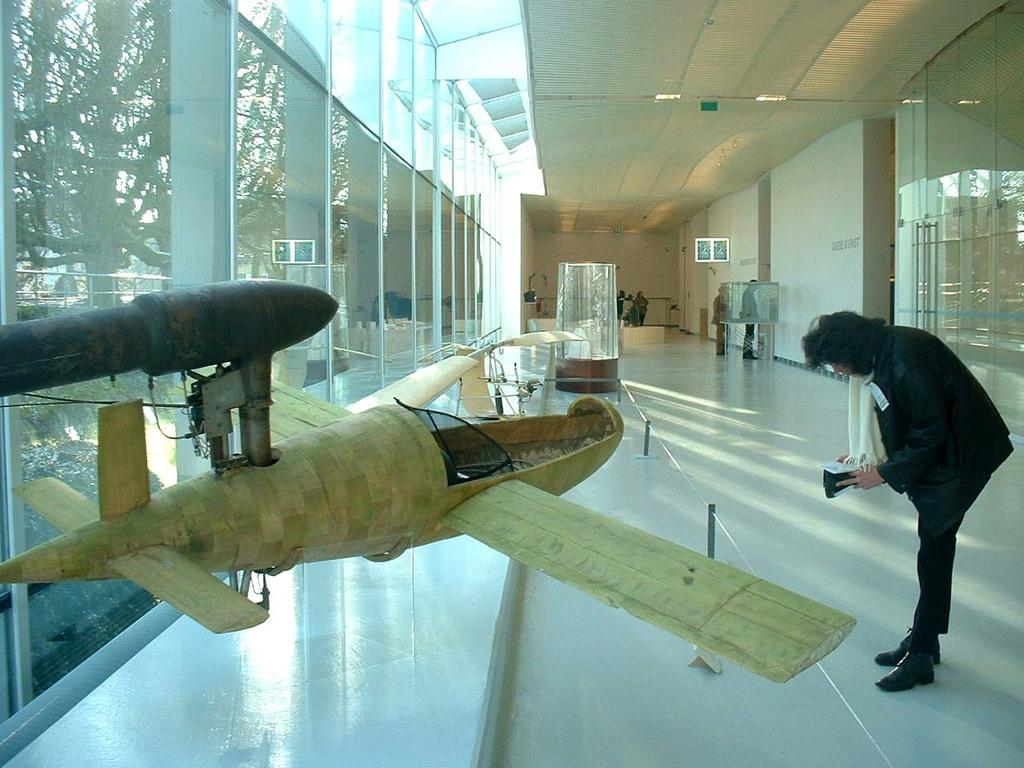What is the main subject of the image? The main subject of the image is a group of people. What can be seen on the left side of the image? There are trees on the left side of the image. What objects are present in the image that people might use? There are glasses visible in the image. What type of item is depicted in a smaller scale in the image? There is a miniature in the image. What can be seen providing illumination in the image? There are lights visible in the image. What type of stew is being served to the group of people in the image? There is no stew present in the image; it features a group of people, trees, glasses, a miniature, and lights. What type of silk fabric is draped over the miniature in the image? There is no silk fabric present in the image; the miniature is depicted without any additional details. 